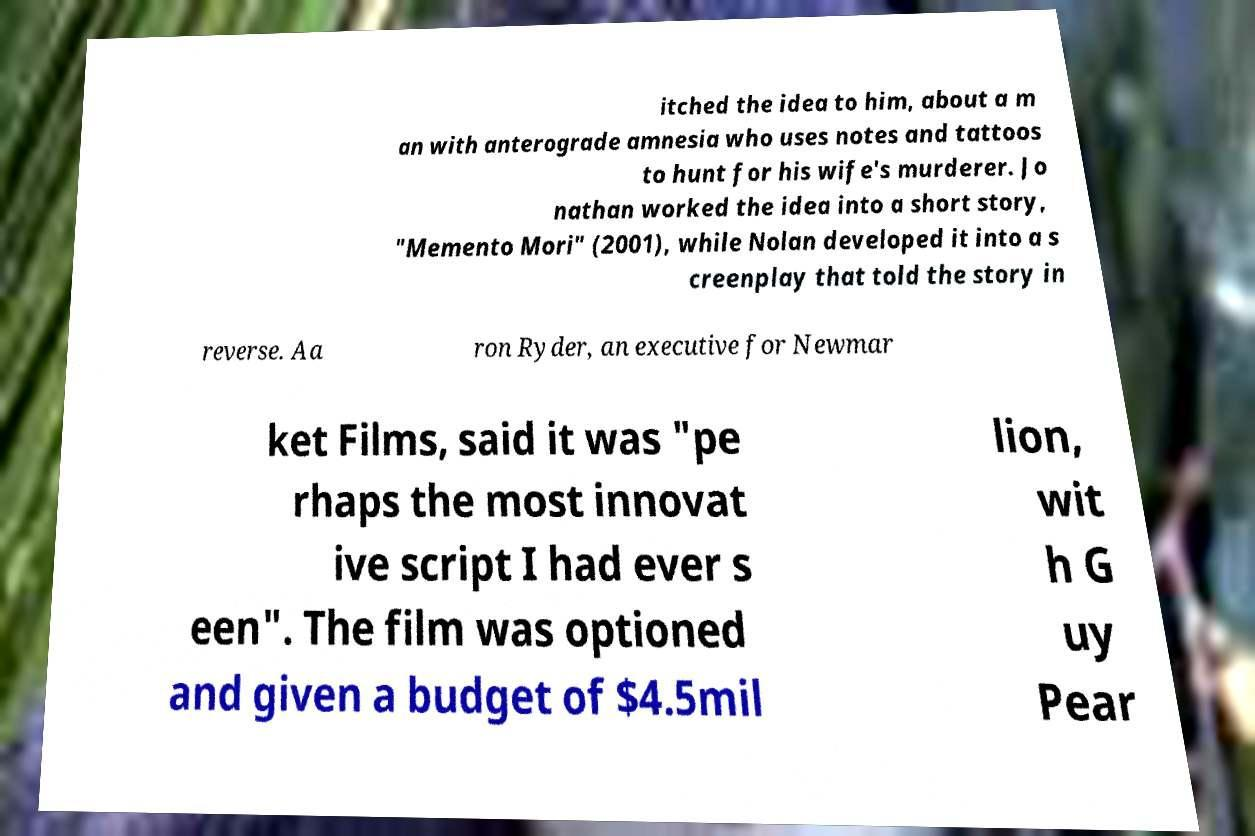What messages or text are displayed in this image? I need them in a readable, typed format. itched the idea to him, about a m an with anterograde amnesia who uses notes and tattoos to hunt for his wife's murderer. Jo nathan worked the idea into a short story, "Memento Mori" (2001), while Nolan developed it into a s creenplay that told the story in reverse. Aa ron Ryder, an executive for Newmar ket Films, said it was "pe rhaps the most innovat ive script I had ever s een". The film was optioned and given a budget of $4.5mil lion, wit h G uy Pear 